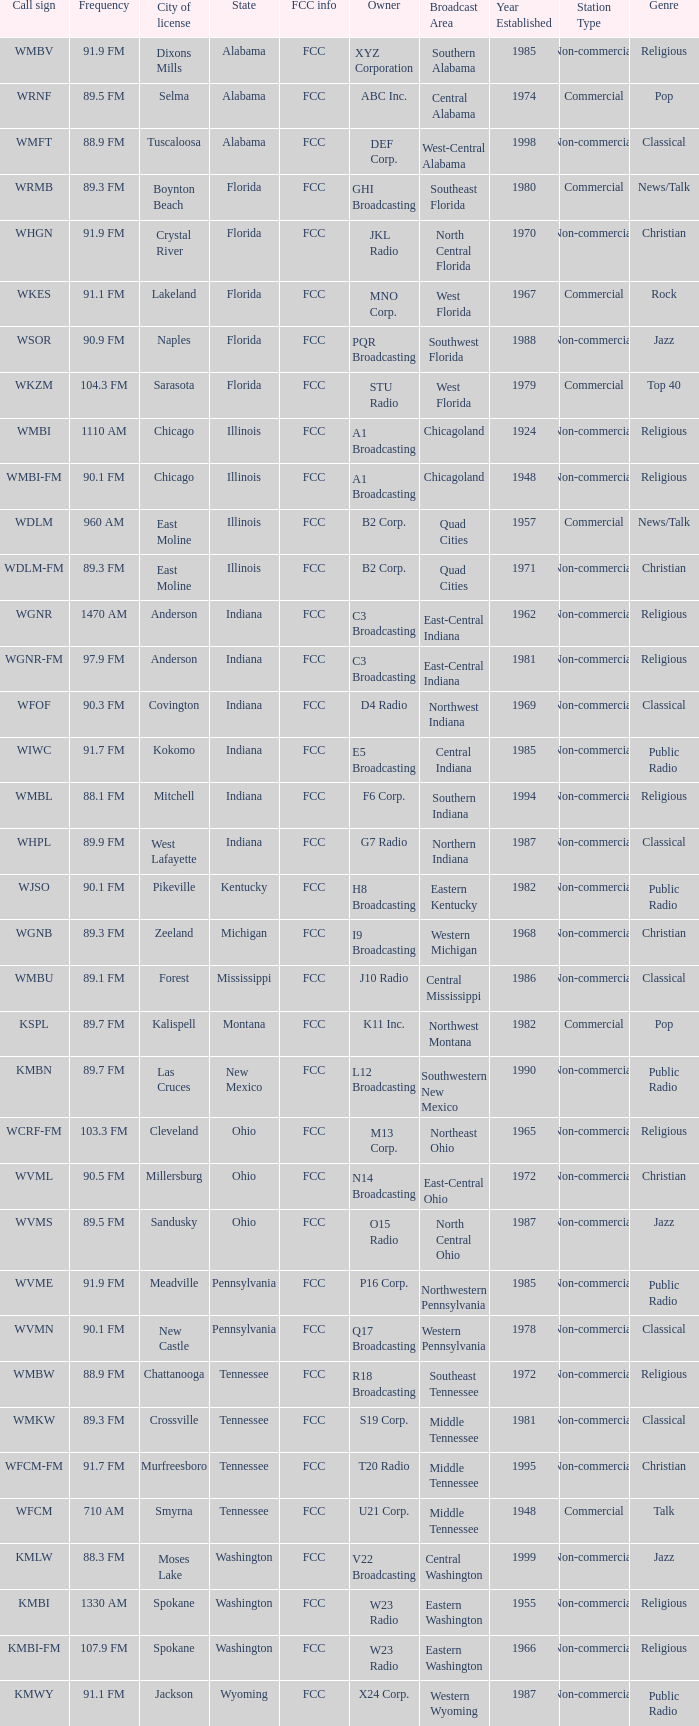What city is 103.3 FM licensed in? Cleveland. 